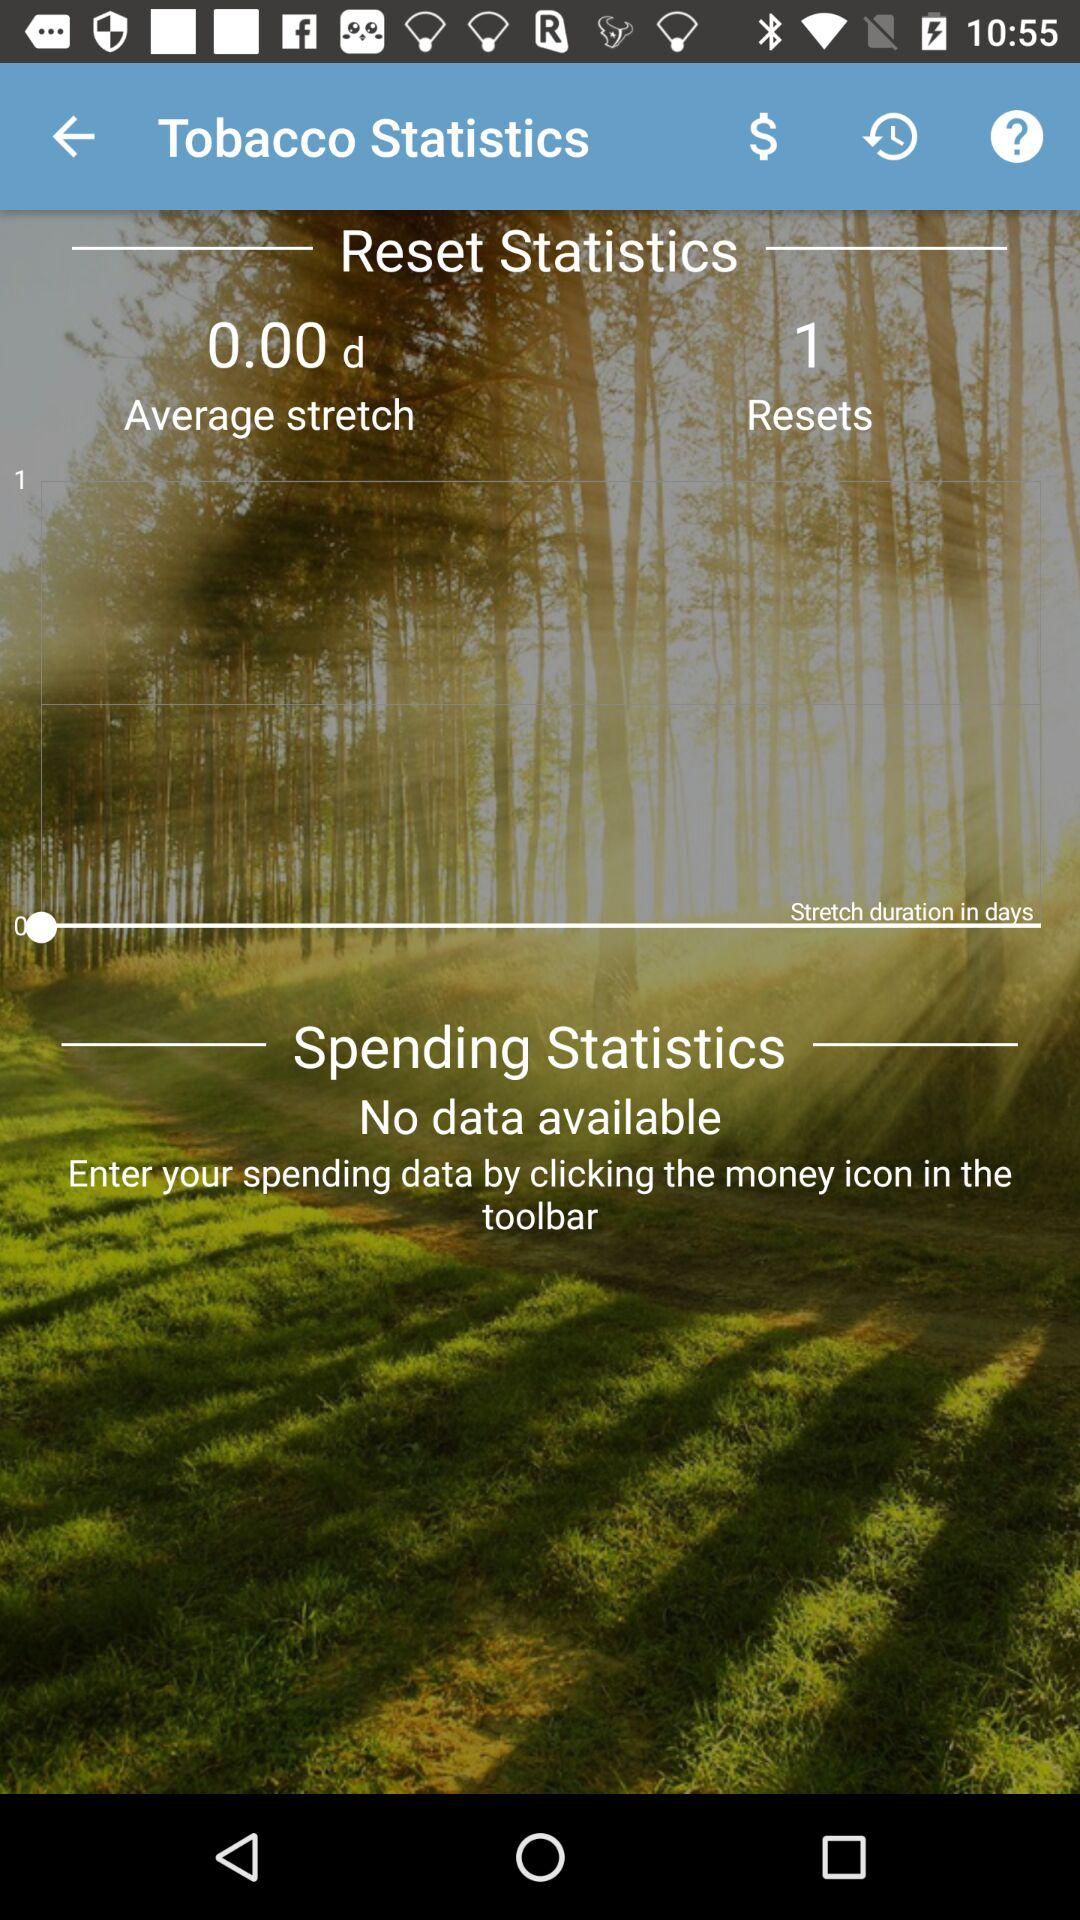Is there any available data? There is no available data. 